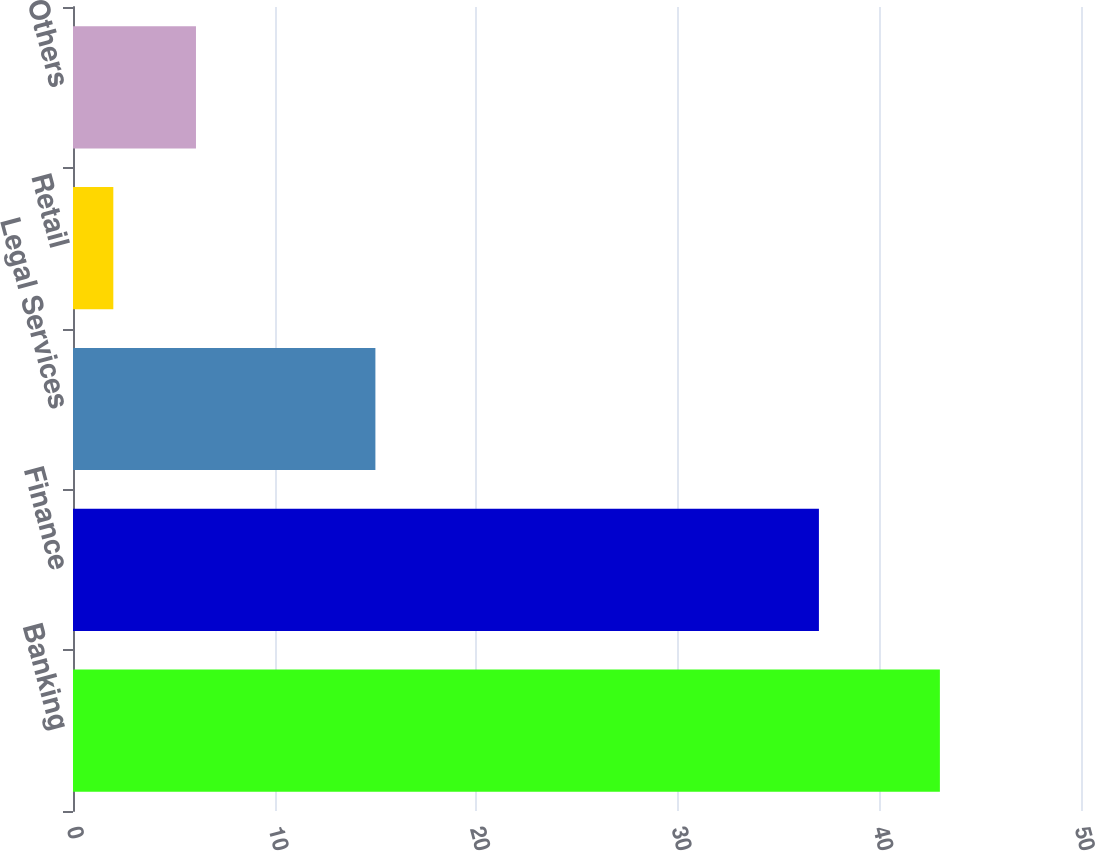<chart> <loc_0><loc_0><loc_500><loc_500><bar_chart><fcel>Banking<fcel>Finance<fcel>Legal Services<fcel>Retail<fcel>Others<nl><fcel>43<fcel>37<fcel>15<fcel>2<fcel>6.1<nl></chart> 